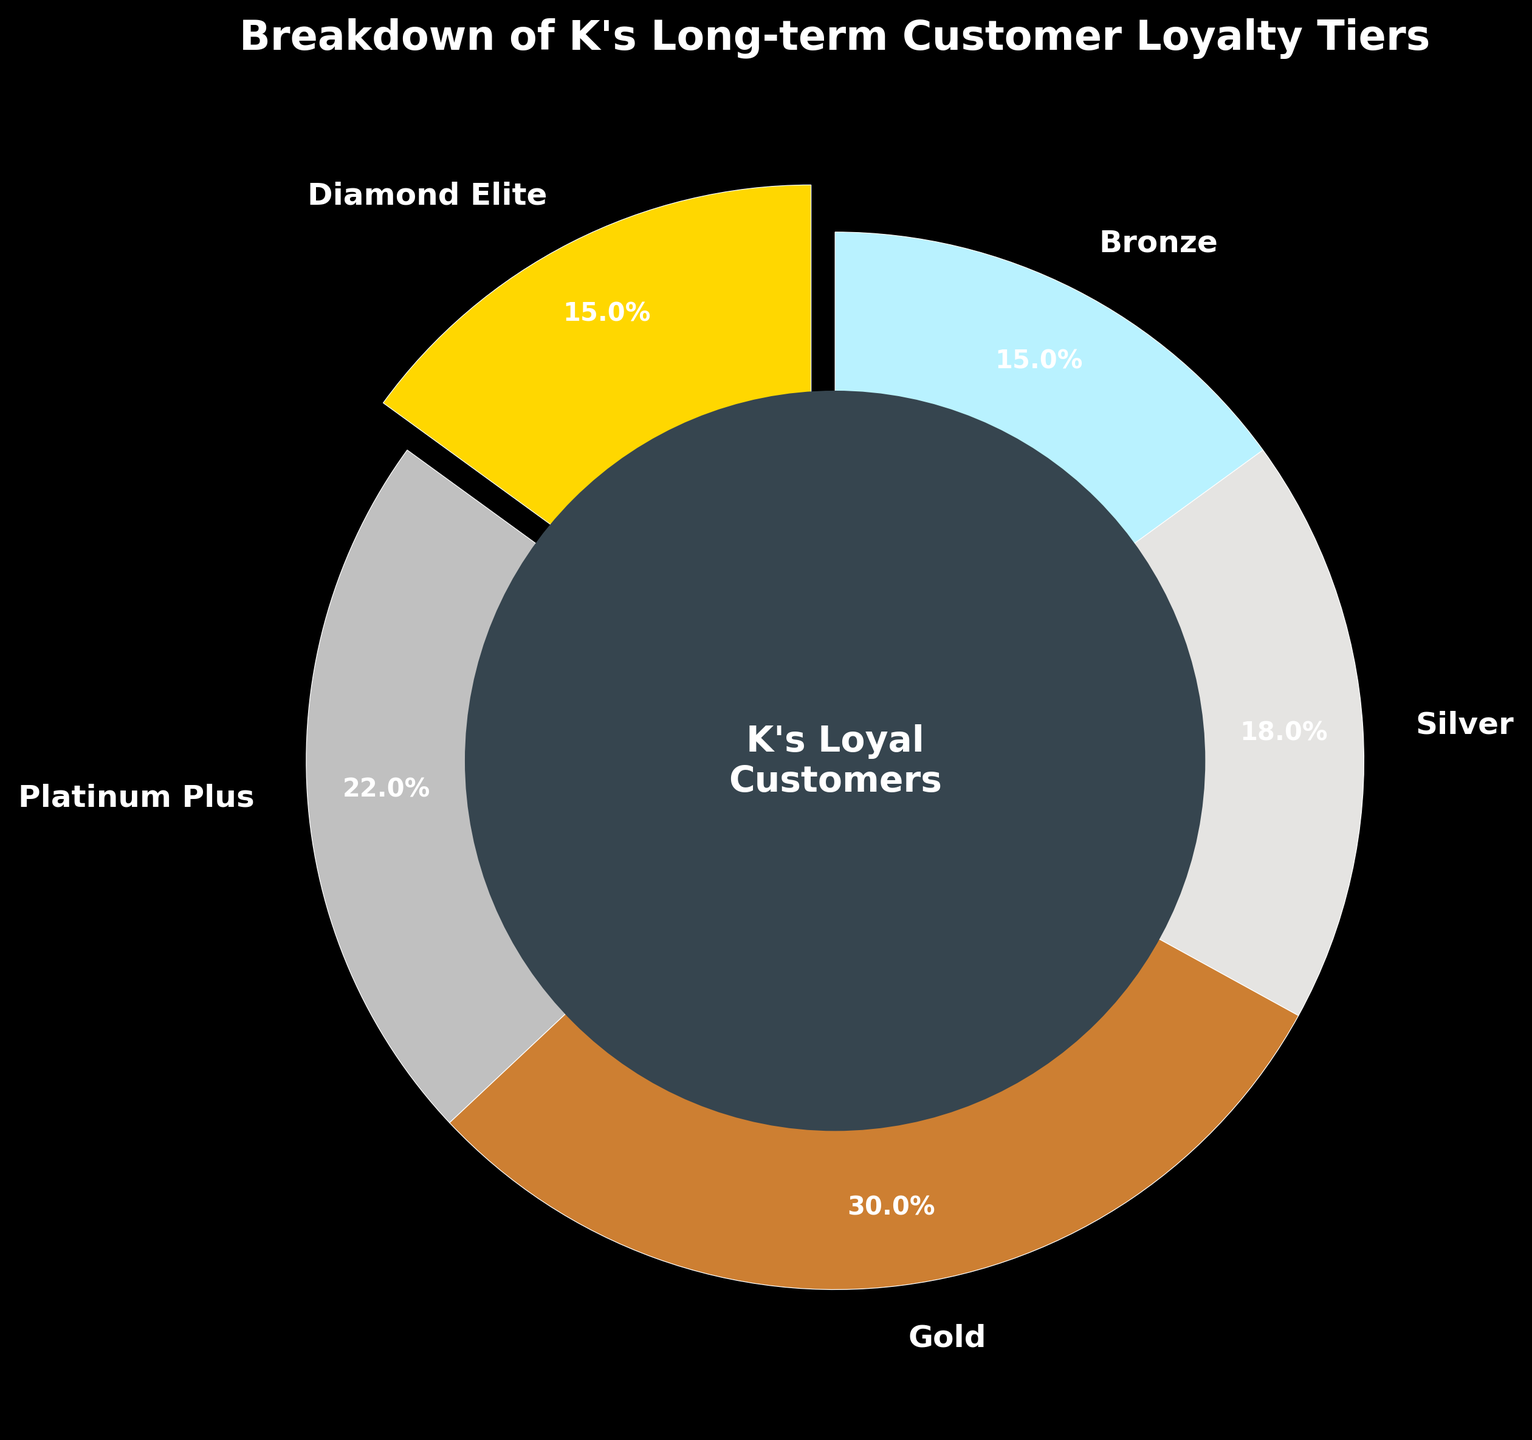What percentage of K's long-term customers fall into the Platinum Plus tier? Referring to the pie chart, the Platinum Plus tier represents 22% of K's long-term customers.
Answer: 22% Which loyalty tier has the smallest percentage of K's long-term customers? The chart shows percentages for each tier. The Diamond Elite and Bronze tiers both have the smallest share at 15% each.
Answer: Diamond Elite and Bronze How much more is the percentage of Gold customers compared to Silver customers? The Gold tier is at 30% and the Silver tier is at 18%. The difference is 30% - 18% = 12%.
Answer: 12% Combine the percentages of the Diamond Elite and Bronze tiers. What do you get? The Diamond Elite tier has 15% and the Bronze tier also has 15%. Combined, it's 15% + 15% = 30%.
Answer: 30% Is the Platinum Plus tier larger or smaller in percentage than the Silver tier? The Platinum Plus tier is at 22%, and the Silver tier is at 18%. Thus, the Platinum Plus tier is larger.
Answer: Larger What is the total percentage of customers who are in the Silver and Gold tiers combined? The Silver tier is 18% and the Gold tier is 30%. Combined, they make 18% + 30% = 48%.
Answer: 48% Which tier is shown to have the second-largest percentage of K's long-term customers? Based on the pie chart, the Gold tier has the largest percentage at 30%, followed by the Platinum Plus tier at 22%.
Answer: Platinum Plus What color is used to represent the Diamond Elite tier in the chart? The Diamond Elite tier is represented by the color gold.
Answer: Gold If you were to group all tiers representing less than 20% each, what is the total percentage of such tiers? Diamond Elite (15%), Silver (18%), and Bronze (15%) all represent less than 20%. The total is 15% + 18% + 15% = 48%.
Answer: 48% Which loyalty tiers together make up half of K's long-term customers? The Gold (30%) and Silver (18%) tiers together make up 30% + 18% = 48%, which is close, but for exactly half, consider Gold 30% and Platinum Plus 22%. Both tiers combine to 30% + 22% = 52%, slightly more than half.
Answer: Gold and Platinum Plus 